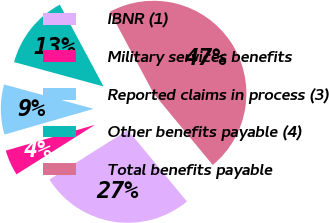Convert chart. <chart><loc_0><loc_0><loc_500><loc_500><pie_chart><fcel>IBNR (1)<fcel>Military services benefits<fcel>Reported claims in process (3)<fcel>Other benefits payable (4)<fcel>Total benefits payable<nl><fcel>27.04%<fcel>4.48%<fcel>8.71%<fcel>12.95%<fcel>46.82%<nl></chart> 